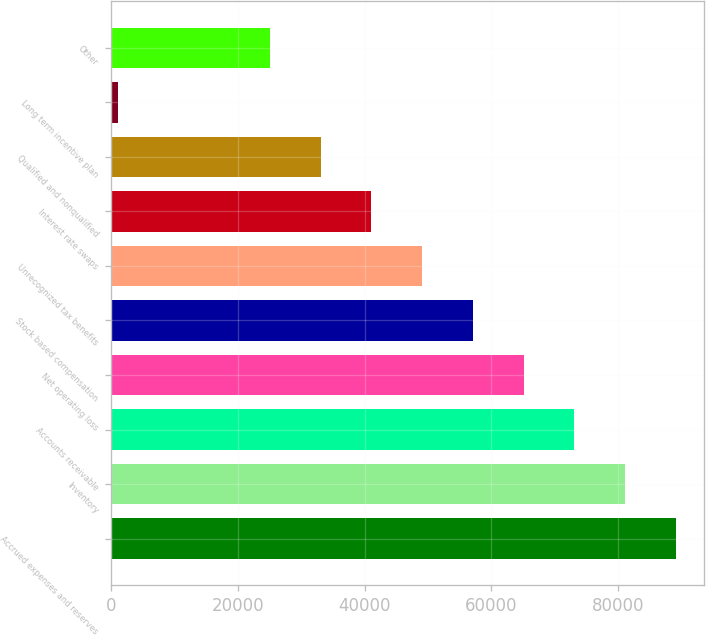Convert chart to OTSL. <chart><loc_0><loc_0><loc_500><loc_500><bar_chart><fcel>Accrued expenses and reserves<fcel>Inventory<fcel>Accounts receivable<fcel>Net operating loss<fcel>Stock based compensation<fcel>Unrecognized tax benefits<fcel>Interest rate swaps<fcel>Qualified and nonqualified<fcel>Long term incentive plan<fcel>Other<nl><fcel>89184.9<fcel>81168<fcel>73151.1<fcel>65134.2<fcel>57117.3<fcel>49100.4<fcel>41083.5<fcel>33066.6<fcel>999<fcel>25049.7<nl></chart> 